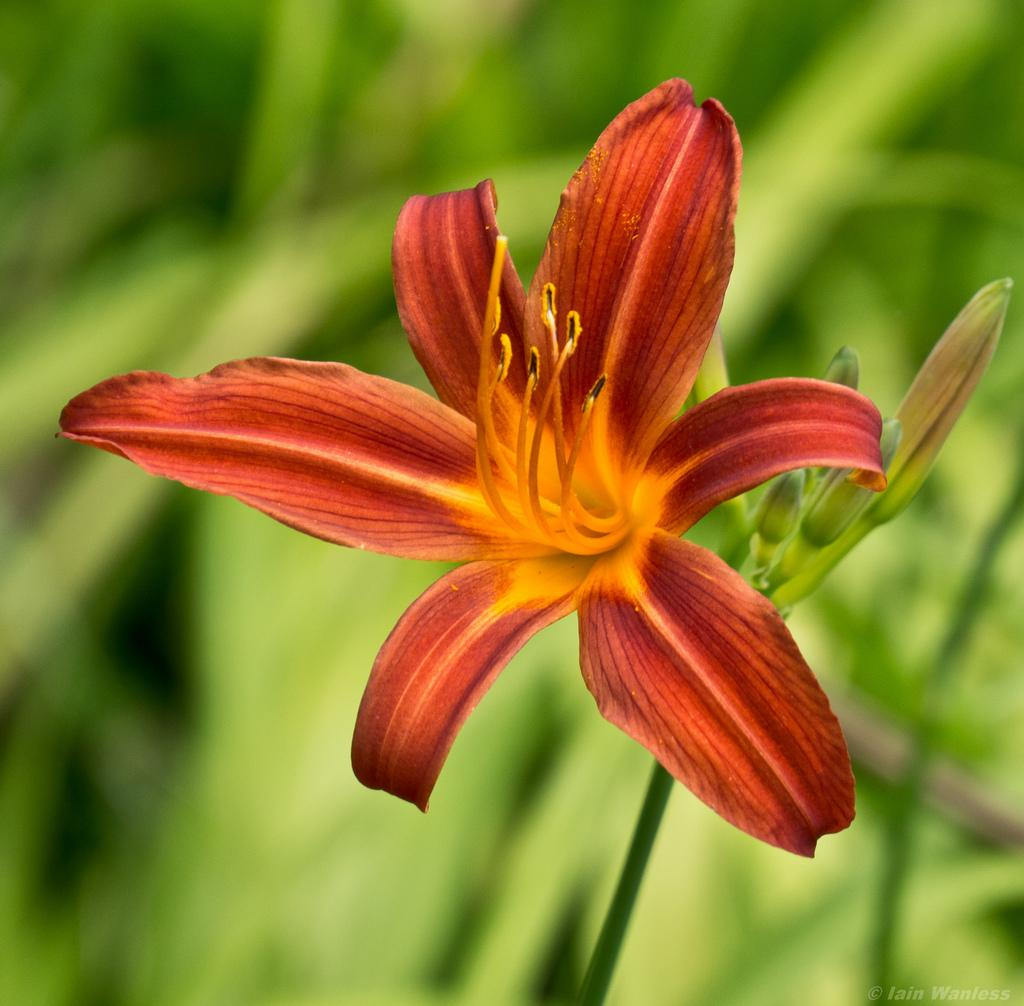What is present in the image? There is a plant in the image. What can be observed about the plant's flower? The plant has a red flower. How is the plant being divided into groups in the image? The image does not show the plant being divided into groups; it only shows the plant with a red flower. 